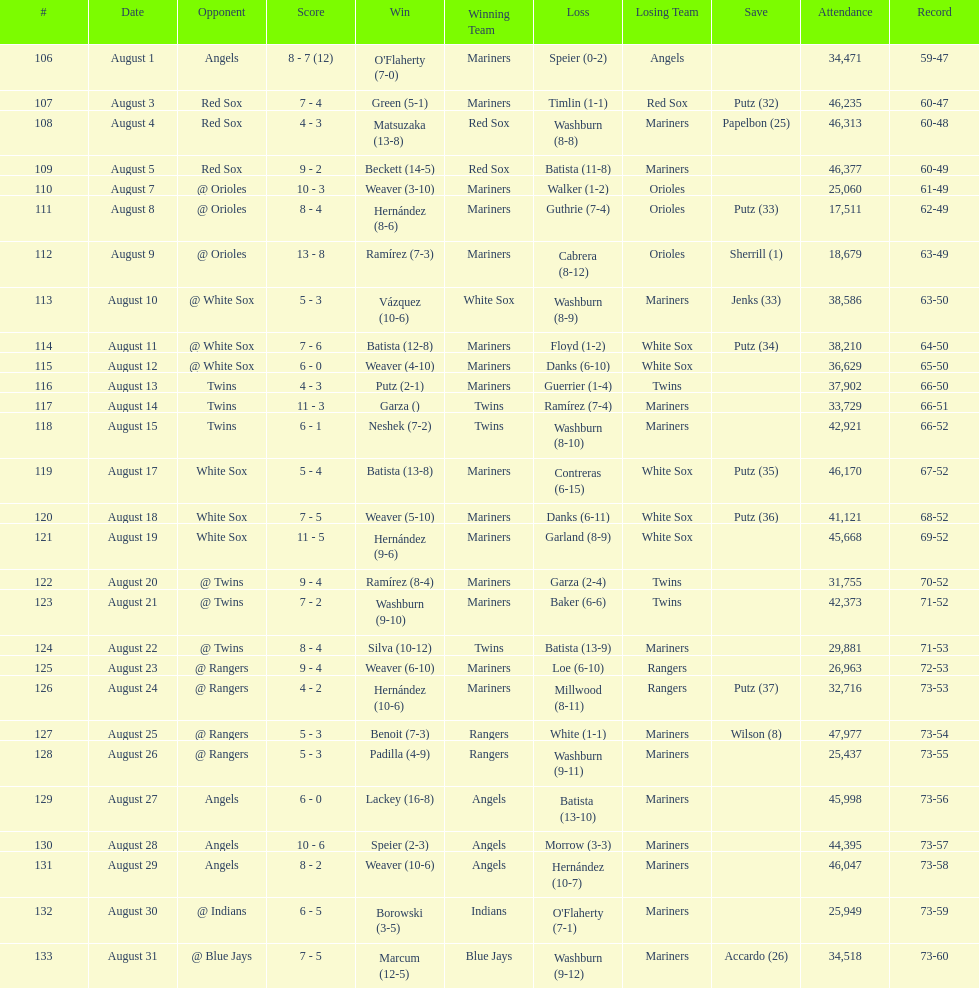Number of wins during stretch 5. 